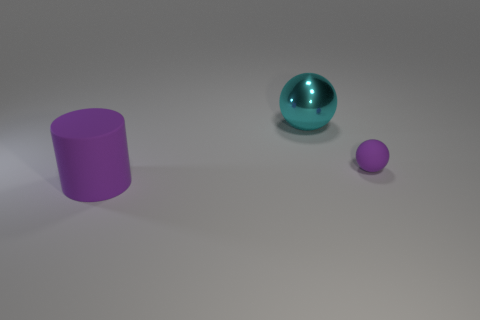Is there anything else that has the same size as the purple sphere?
Provide a succinct answer. No. Is there anything else that is the same material as the cyan thing?
Ensure brevity in your answer.  No. The other rubber thing that is the same shape as the cyan object is what size?
Provide a succinct answer. Small. Does the object to the right of the large shiny sphere have the same material as the ball that is behind the small sphere?
Your answer should be very brief. No. How many shiny things are large purple things or brown cylinders?
Ensure brevity in your answer.  0. What material is the thing to the left of the sphere behind the small purple rubber object that is right of the matte cylinder?
Your response must be concise. Rubber. Do the big thing behind the big cylinder and the rubber object that is behind the big matte cylinder have the same shape?
Your answer should be compact. Yes. What is the color of the rubber thing to the right of the rubber thing left of the small rubber thing?
Give a very brief answer. Purple. How many spheres are either small purple rubber things or big yellow objects?
Provide a succinct answer. 1. How many large things are behind the purple matte ball behind the purple rubber object that is left of the small purple ball?
Your response must be concise. 1. 